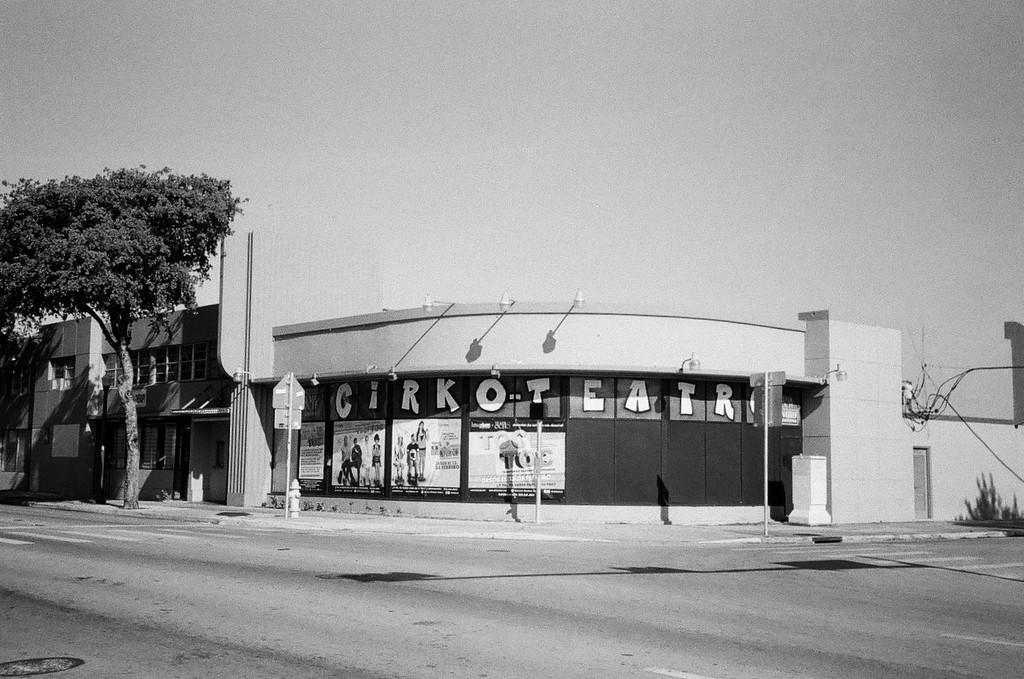Describe this image in one or two sentences. This picture is in black and white. In the center, there is a building with some text. Before it, there is a road. Towards the left, there is a tree. On the top, there is a sky. 